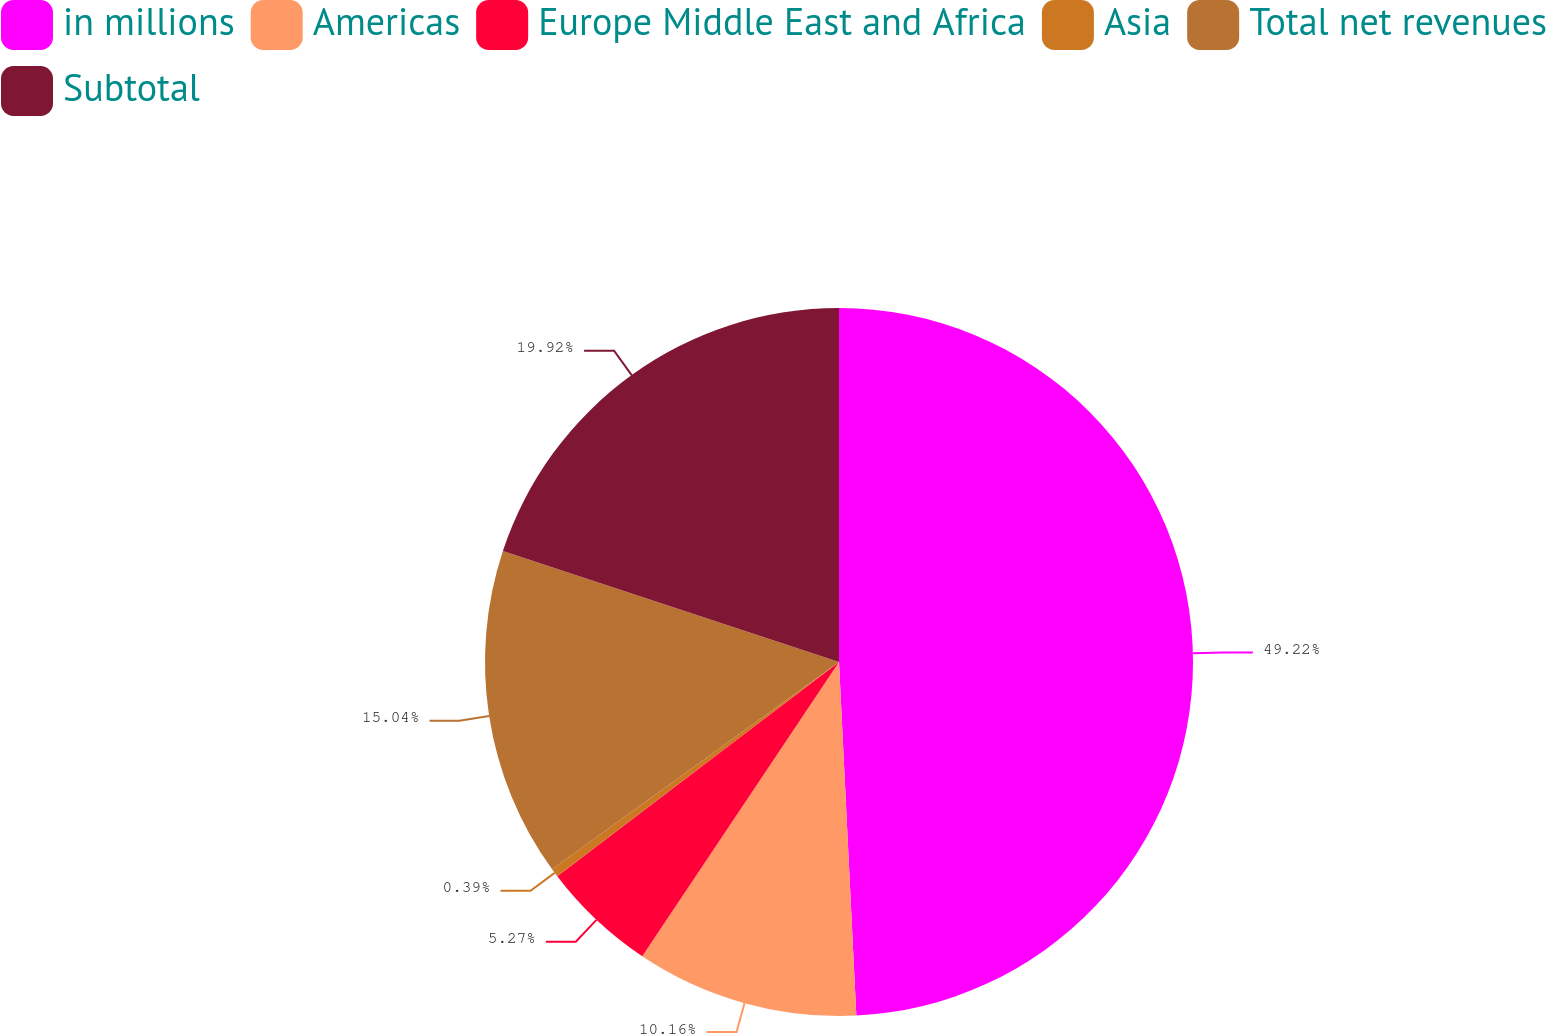Convert chart to OTSL. <chart><loc_0><loc_0><loc_500><loc_500><pie_chart><fcel>in millions<fcel>Americas<fcel>Europe Middle East and Africa<fcel>Asia<fcel>Total net revenues<fcel>Subtotal<nl><fcel>49.22%<fcel>10.16%<fcel>5.27%<fcel>0.39%<fcel>15.04%<fcel>19.92%<nl></chart> 